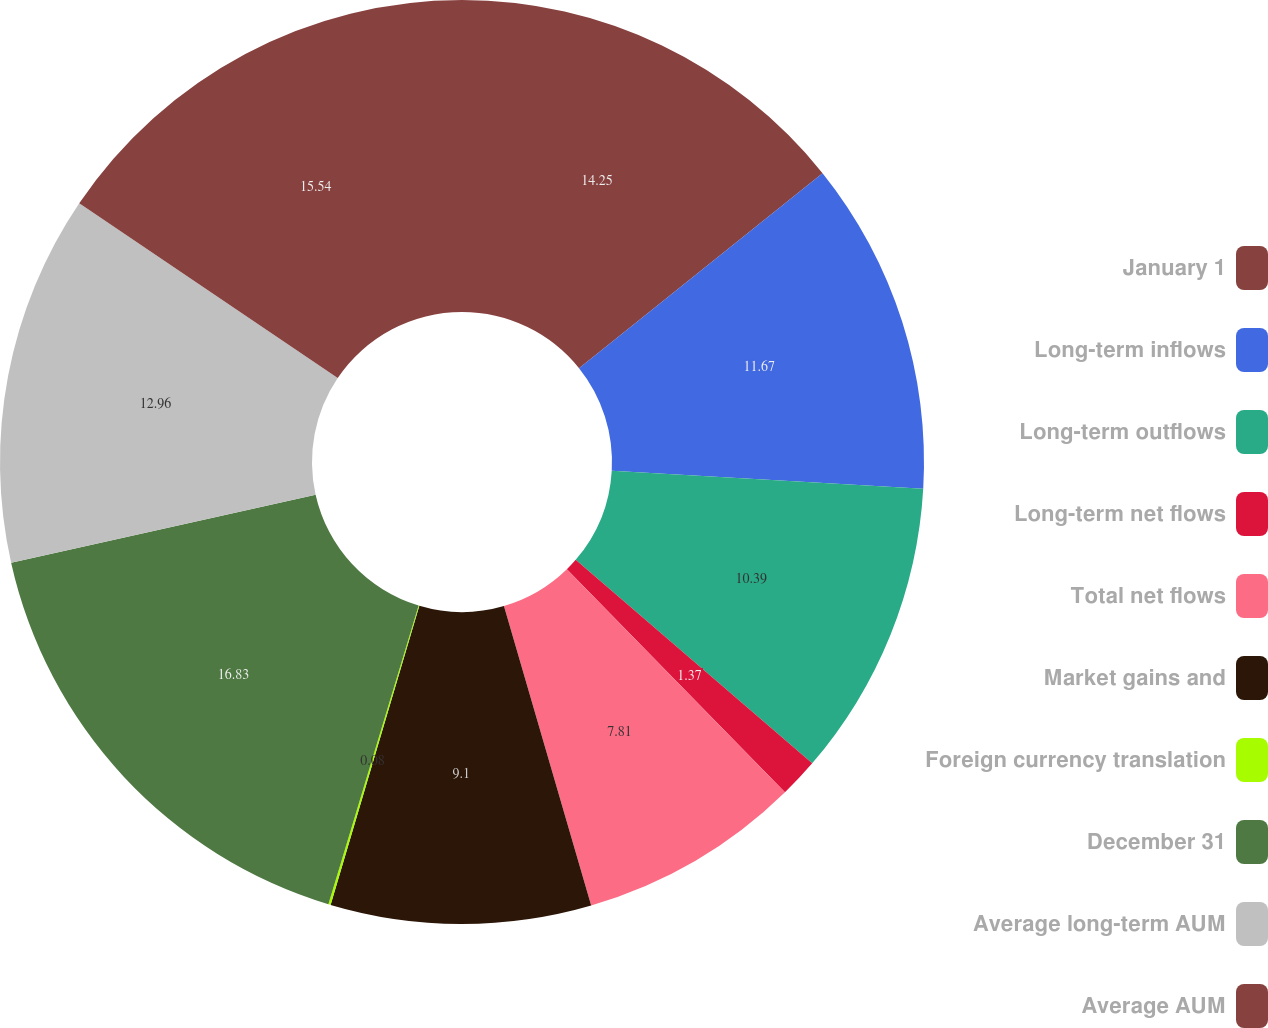Convert chart to OTSL. <chart><loc_0><loc_0><loc_500><loc_500><pie_chart><fcel>January 1<fcel>Long-term inflows<fcel>Long-term outflows<fcel>Long-term net flows<fcel>Total net flows<fcel>Market gains and<fcel>Foreign currency translation<fcel>December 31<fcel>Average long-term AUM<fcel>Average AUM<nl><fcel>14.25%<fcel>11.67%<fcel>10.39%<fcel>1.37%<fcel>7.81%<fcel>9.1%<fcel>0.08%<fcel>16.83%<fcel>12.96%<fcel>15.54%<nl></chart> 